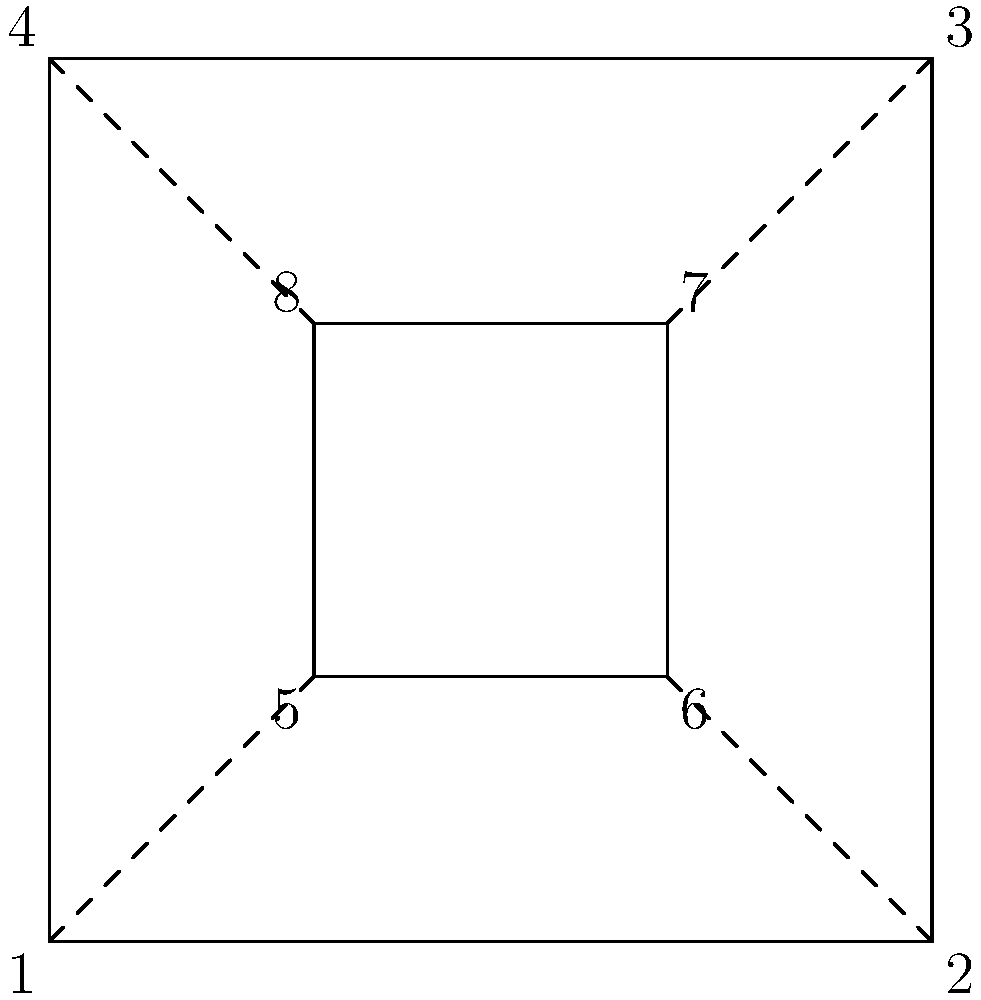In a crucial scene, you need to create a shot that conveys both isolation and confinement. Given the diagram representing different camera angles, which sequence of shots would best achieve this effect, starting from the widest angle and moving to the tightest? To create a shot that conveys both isolation and confinement, we need to consider the emotional impact of each frame and how the sequence of shots can build tension:

1. Start with the widest angle (outer square) to establish the scene and create a sense of isolation:
   - Angles 1, 2, 3, or 4 would work, but let's choose 1 for the starting point.

2. Move to a slightly tighter shot to begin focusing on the subject:
   - Angle 4 would create a diagonal movement, adding visual interest.

3. Continue tightening the frame to increase the feeling of confinement:
   - Angle 8 maintains the diagonal movement and brings us closer to the subject.

4. End with the tightest shot to maximize the sense of confinement:
   - Angle 7 completes the diagonal movement and provides the tightest frame.

This sequence (1 → 4 → 8 → 7) creates a visual journey that starts wide, establishing isolation, and progressively tightens to convey confinement. The diagonal movement adds dynamism to the sequence, enhancing the emotional impact.
Answer: 1 → 4 → 8 → 7 